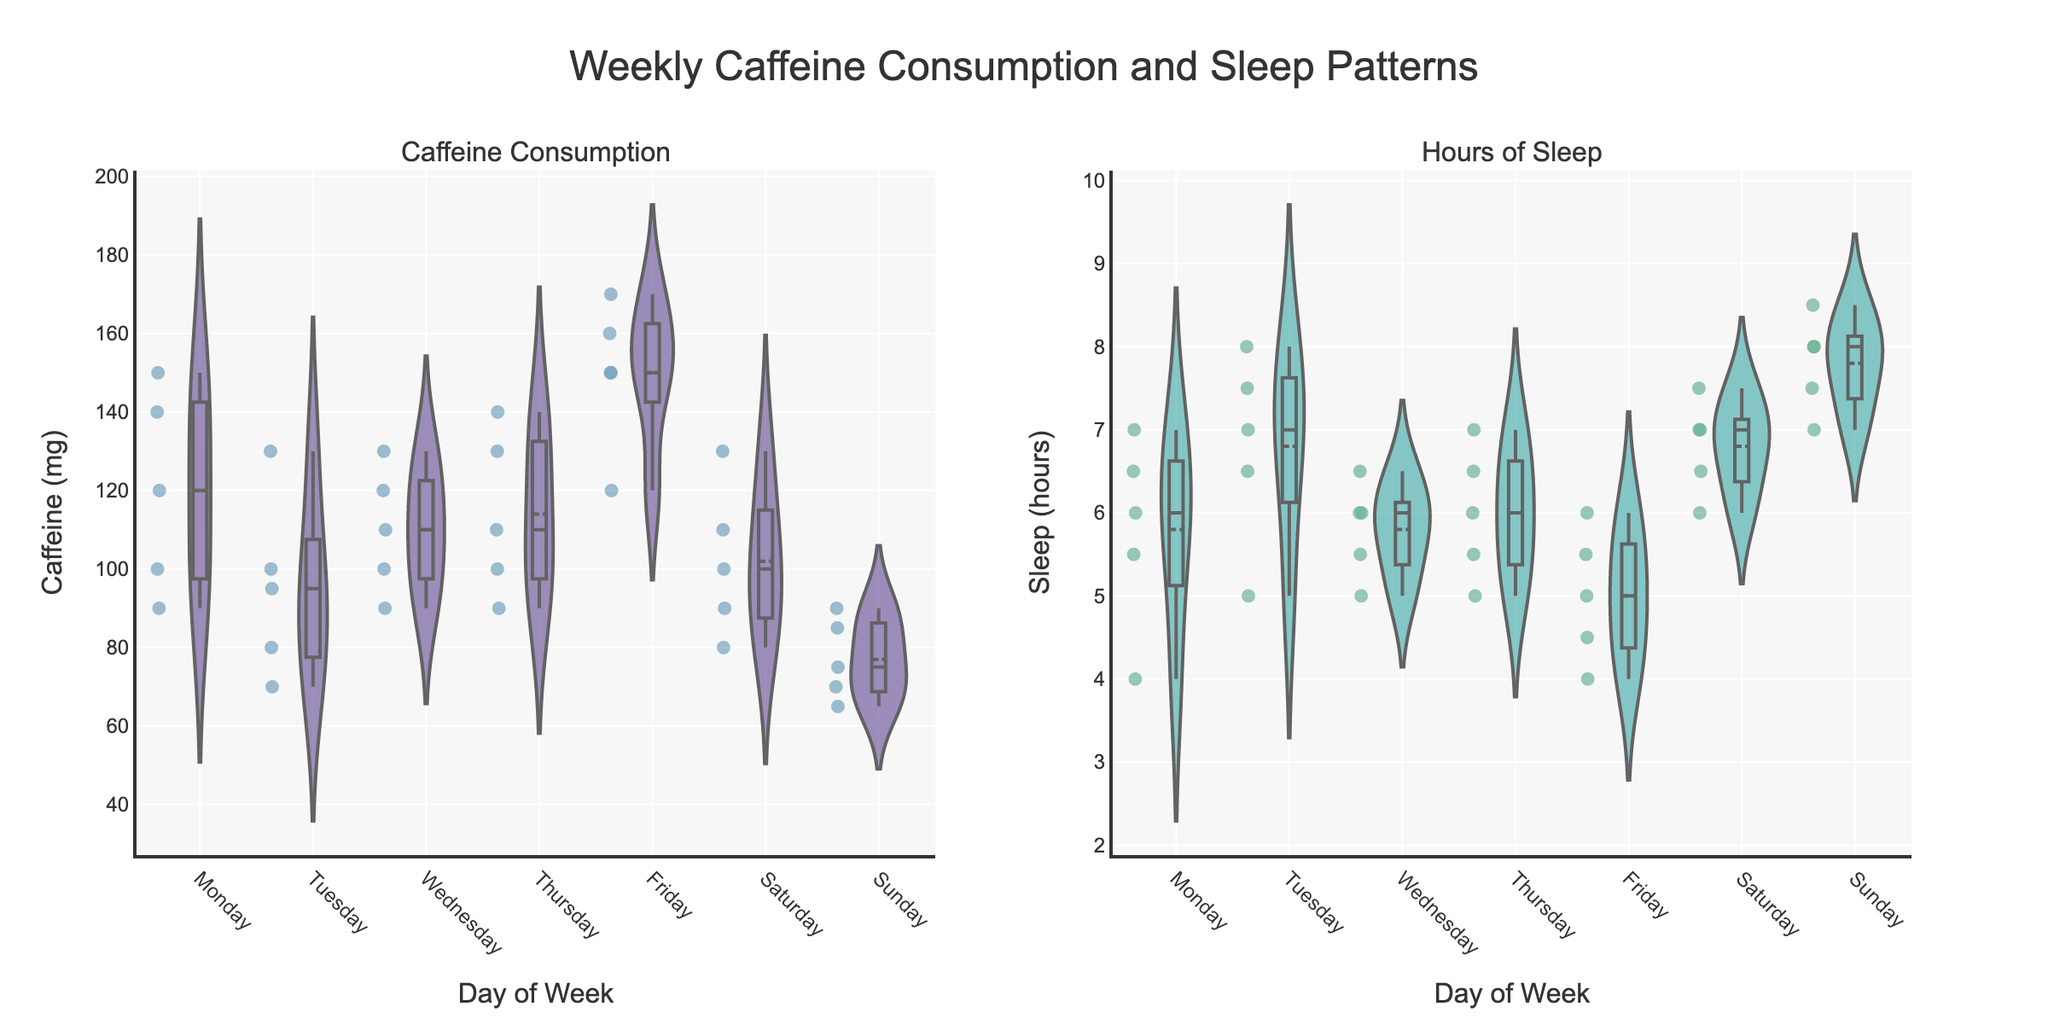What is the title of the figure? The title of the figure is prominently displayed at the top center. It provides an overall description of what the figure is about.
Answer: Weekly Caffeine Consumption and Sleep Patterns On which day is the highest median caffeine consumption recorded? Examine the position of the median line (white line) in the violin plot for each day. The highest median line indicates the highest median caffeine consumption.
Answer: Friday Which day has the widest range of caffeine consumption values? Look at the spread of the violin plot for caffeine consumption for each day. The day with the widest range (longest vertical area) is the day with the widest range.
Answer: Friday How does the sleep pattern on Monday compare to Sunday in terms of median sleep hours? Compare the position of the median line (white line) in the violin plot for sleep hours for Monday and Sunday. The higher median line indicates higher median sleep hours.
Answer: Higher on Sunday Which day has the lowest variability in sleep hours? Check the violin plot for sleep hours. The day with the narrowest spread (least vertical extent) indicates the lowest variability in sleep hours.
Answer: Sunday Compare the mean caffeine consumption on Wednesday and Friday. Which is higher? The mean is indicated by a dashed line on the violin plot. Compare the positions of these lines for Wednesday and Friday to see which is higher.
Answer: Friday What can you say about the distribution of sleep hours on Tuesday? Observe the shape and spread of the violin plot for sleep hours on Tuesday. A symmetrical shape means the distribution is more normal, while a skewed shape indicates asymmetry.
Answer: Fairly symmetrical What's the range of sleep hours on Thursday? The range can be determined by observing the top and bottom points of the violin plot for sleep hours on Thursday.
Answer: 5 to 7 hours How does the caffeine consumption pattern on Saturday compare to Tuesday? Compare the spread, mean, and median lines of the violin plots for caffeine consumption on Saturday and Tuesday.
Answer: Higher median and wider spread on Saturday Which day shows the least median difference between caffeine consumption and sleep hours? Compare the medians (white lines) of caffeine consumption and sleep hours across each day. The smallest distance indicates the least difference.
Answer: Thursday 